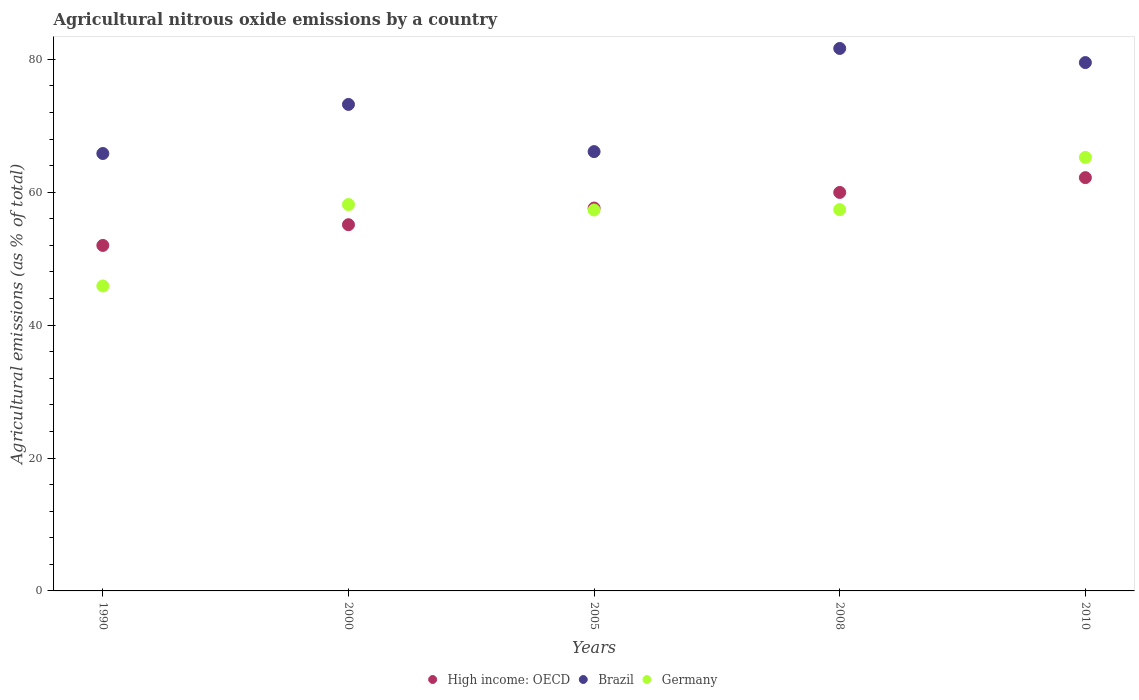How many different coloured dotlines are there?
Make the answer very short. 3. Is the number of dotlines equal to the number of legend labels?
Ensure brevity in your answer.  Yes. What is the amount of agricultural nitrous oxide emitted in Brazil in 2008?
Your answer should be very brief. 81.63. Across all years, what is the maximum amount of agricultural nitrous oxide emitted in High income: OECD?
Your response must be concise. 62.19. Across all years, what is the minimum amount of agricultural nitrous oxide emitted in High income: OECD?
Offer a terse response. 51.99. In which year was the amount of agricultural nitrous oxide emitted in High income: OECD minimum?
Keep it short and to the point. 1990. What is the total amount of agricultural nitrous oxide emitted in Germany in the graph?
Provide a succinct answer. 283.97. What is the difference between the amount of agricultural nitrous oxide emitted in Germany in 2008 and that in 2010?
Give a very brief answer. -7.85. What is the difference between the amount of agricultural nitrous oxide emitted in High income: OECD in 2010 and the amount of agricultural nitrous oxide emitted in Germany in 2008?
Your answer should be compact. 4.81. What is the average amount of agricultural nitrous oxide emitted in High income: OECD per year?
Provide a short and direct response. 57.37. In the year 2000, what is the difference between the amount of agricultural nitrous oxide emitted in High income: OECD and amount of agricultural nitrous oxide emitted in Brazil?
Keep it short and to the point. -18.1. What is the ratio of the amount of agricultural nitrous oxide emitted in High income: OECD in 2000 to that in 2010?
Provide a succinct answer. 0.89. Is the amount of agricultural nitrous oxide emitted in Germany in 2008 less than that in 2010?
Make the answer very short. Yes. Is the difference between the amount of agricultural nitrous oxide emitted in High income: OECD in 2000 and 2010 greater than the difference between the amount of agricultural nitrous oxide emitted in Brazil in 2000 and 2010?
Offer a very short reply. No. What is the difference between the highest and the second highest amount of agricultural nitrous oxide emitted in Brazil?
Provide a succinct answer. 2.12. What is the difference between the highest and the lowest amount of agricultural nitrous oxide emitted in High income: OECD?
Offer a terse response. 10.2. In how many years, is the amount of agricultural nitrous oxide emitted in Germany greater than the average amount of agricultural nitrous oxide emitted in Germany taken over all years?
Provide a short and direct response. 4. Is the sum of the amount of agricultural nitrous oxide emitted in High income: OECD in 2000 and 2008 greater than the maximum amount of agricultural nitrous oxide emitted in Brazil across all years?
Keep it short and to the point. Yes. Is the amount of agricultural nitrous oxide emitted in Germany strictly less than the amount of agricultural nitrous oxide emitted in Brazil over the years?
Provide a short and direct response. Yes. What is the difference between two consecutive major ticks on the Y-axis?
Your answer should be very brief. 20. Does the graph contain any zero values?
Ensure brevity in your answer.  No. Where does the legend appear in the graph?
Offer a very short reply. Bottom center. How many legend labels are there?
Keep it short and to the point. 3. What is the title of the graph?
Give a very brief answer. Agricultural nitrous oxide emissions by a country. What is the label or title of the X-axis?
Offer a very short reply. Years. What is the label or title of the Y-axis?
Your answer should be compact. Agricultural emissions (as % of total). What is the Agricultural emissions (as % of total) in High income: OECD in 1990?
Your response must be concise. 51.99. What is the Agricultural emissions (as % of total) in Brazil in 1990?
Ensure brevity in your answer.  65.82. What is the Agricultural emissions (as % of total) of Germany in 1990?
Make the answer very short. 45.89. What is the Agricultural emissions (as % of total) of High income: OECD in 2000?
Give a very brief answer. 55.1. What is the Agricultural emissions (as % of total) of Brazil in 2000?
Your answer should be very brief. 73.21. What is the Agricultural emissions (as % of total) of Germany in 2000?
Your answer should be very brief. 58.14. What is the Agricultural emissions (as % of total) in High income: OECD in 2005?
Give a very brief answer. 57.61. What is the Agricultural emissions (as % of total) in Brazil in 2005?
Your answer should be very brief. 66.11. What is the Agricultural emissions (as % of total) of Germany in 2005?
Offer a terse response. 57.32. What is the Agricultural emissions (as % of total) of High income: OECD in 2008?
Keep it short and to the point. 59.96. What is the Agricultural emissions (as % of total) of Brazil in 2008?
Your answer should be compact. 81.63. What is the Agricultural emissions (as % of total) in Germany in 2008?
Keep it short and to the point. 57.38. What is the Agricultural emissions (as % of total) in High income: OECD in 2010?
Provide a short and direct response. 62.19. What is the Agricultural emissions (as % of total) of Brazil in 2010?
Give a very brief answer. 79.5. What is the Agricultural emissions (as % of total) in Germany in 2010?
Ensure brevity in your answer.  65.23. Across all years, what is the maximum Agricultural emissions (as % of total) of High income: OECD?
Provide a succinct answer. 62.19. Across all years, what is the maximum Agricultural emissions (as % of total) of Brazil?
Give a very brief answer. 81.63. Across all years, what is the maximum Agricultural emissions (as % of total) in Germany?
Your answer should be very brief. 65.23. Across all years, what is the minimum Agricultural emissions (as % of total) of High income: OECD?
Provide a short and direct response. 51.99. Across all years, what is the minimum Agricultural emissions (as % of total) of Brazil?
Keep it short and to the point. 65.82. Across all years, what is the minimum Agricultural emissions (as % of total) in Germany?
Offer a terse response. 45.89. What is the total Agricultural emissions (as % of total) in High income: OECD in the graph?
Make the answer very short. 286.86. What is the total Agricultural emissions (as % of total) in Brazil in the graph?
Keep it short and to the point. 366.26. What is the total Agricultural emissions (as % of total) in Germany in the graph?
Offer a terse response. 283.97. What is the difference between the Agricultural emissions (as % of total) in High income: OECD in 1990 and that in 2000?
Offer a very short reply. -3.12. What is the difference between the Agricultural emissions (as % of total) of Brazil in 1990 and that in 2000?
Offer a terse response. -7.39. What is the difference between the Agricultural emissions (as % of total) of Germany in 1990 and that in 2000?
Ensure brevity in your answer.  -12.25. What is the difference between the Agricultural emissions (as % of total) in High income: OECD in 1990 and that in 2005?
Keep it short and to the point. -5.62. What is the difference between the Agricultural emissions (as % of total) in Brazil in 1990 and that in 2005?
Ensure brevity in your answer.  -0.29. What is the difference between the Agricultural emissions (as % of total) in Germany in 1990 and that in 2005?
Provide a short and direct response. -11.43. What is the difference between the Agricultural emissions (as % of total) of High income: OECD in 1990 and that in 2008?
Your answer should be compact. -7.97. What is the difference between the Agricultural emissions (as % of total) of Brazil in 1990 and that in 2008?
Your answer should be very brief. -15.81. What is the difference between the Agricultural emissions (as % of total) of Germany in 1990 and that in 2008?
Provide a succinct answer. -11.49. What is the difference between the Agricultural emissions (as % of total) in High income: OECD in 1990 and that in 2010?
Your answer should be compact. -10.2. What is the difference between the Agricultural emissions (as % of total) of Brazil in 1990 and that in 2010?
Your answer should be very brief. -13.68. What is the difference between the Agricultural emissions (as % of total) in Germany in 1990 and that in 2010?
Provide a short and direct response. -19.34. What is the difference between the Agricultural emissions (as % of total) of High income: OECD in 2000 and that in 2005?
Offer a terse response. -2.51. What is the difference between the Agricultural emissions (as % of total) in Brazil in 2000 and that in 2005?
Make the answer very short. 7.1. What is the difference between the Agricultural emissions (as % of total) in Germany in 2000 and that in 2005?
Offer a terse response. 0.82. What is the difference between the Agricultural emissions (as % of total) of High income: OECD in 2000 and that in 2008?
Your answer should be compact. -4.86. What is the difference between the Agricultural emissions (as % of total) of Brazil in 2000 and that in 2008?
Provide a short and direct response. -8.42. What is the difference between the Agricultural emissions (as % of total) of Germany in 2000 and that in 2008?
Make the answer very short. 0.76. What is the difference between the Agricultural emissions (as % of total) of High income: OECD in 2000 and that in 2010?
Offer a very short reply. -7.09. What is the difference between the Agricultural emissions (as % of total) of Brazil in 2000 and that in 2010?
Offer a terse response. -6.3. What is the difference between the Agricultural emissions (as % of total) of Germany in 2000 and that in 2010?
Ensure brevity in your answer.  -7.09. What is the difference between the Agricultural emissions (as % of total) of High income: OECD in 2005 and that in 2008?
Your answer should be very brief. -2.35. What is the difference between the Agricultural emissions (as % of total) of Brazil in 2005 and that in 2008?
Keep it short and to the point. -15.52. What is the difference between the Agricultural emissions (as % of total) in Germany in 2005 and that in 2008?
Give a very brief answer. -0.06. What is the difference between the Agricultural emissions (as % of total) in High income: OECD in 2005 and that in 2010?
Provide a succinct answer. -4.58. What is the difference between the Agricultural emissions (as % of total) in Brazil in 2005 and that in 2010?
Your answer should be very brief. -13.4. What is the difference between the Agricultural emissions (as % of total) in Germany in 2005 and that in 2010?
Your answer should be compact. -7.91. What is the difference between the Agricultural emissions (as % of total) in High income: OECD in 2008 and that in 2010?
Your response must be concise. -2.23. What is the difference between the Agricultural emissions (as % of total) of Brazil in 2008 and that in 2010?
Your response must be concise. 2.12. What is the difference between the Agricultural emissions (as % of total) of Germany in 2008 and that in 2010?
Your answer should be very brief. -7.86. What is the difference between the Agricultural emissions (as % of total) in High income: OECD in 1990 and the Agricultural emissions (as % of total) in Brazil in 2000?
Provide a short and direct response. -21.22. What is the difference between the Agricultural emissions (as % of total) in High income: OECD in 1990 and the Agricultural emissions (as % of total) in Germany in 2000?
Provide a short and direct response. -6.15. What is the difference between the Agricultural emissions (as % of total) of Brazil in 1990 and the Agricultural emissions (as % of total) of Germany in 2000?
Offer a terse response. 7.68. What is the difference between the Agricultural emissions (as % of total) of High income: OECD in 1990 and the Agricultural emissions (as % of total) of Brazil in 2005?
Ensure brevity in your answer.  -14.12. What is the difference between the Agricultural emissions (as % of total) of High income: OECD in 1990 and the Agricultural emissions (as % of total) of Germany in 2005?
Provide a short and direct response. -5.33. What is the difference between the Agricultural emissions (as % of total) of Brazil in 1990 and the Agricultural emissions (as % of total) of Germany in 2005?
Your answer should be compact. 8.5. What is the difference between the Agricultural emissions (as % of total) of High income: OECD in 1990 and the Agricultural emissions (as % of total) of Brazil in 2008?
Your answer should be very brief. -29.64. What is the difference between the Agricultural emissions (as % of total) of High income: OECD in 1990 and the Agricultural emissions (as % of total) of Germany in 2008?
Offer a terse response. -5.39. What is the difference between the Agricultural emissions (as % of total) in Brazil in 1990 and the Agricultural emissions (as % of total) in Germany in 2008?
Keep it short and to the point. 8.44. What is the difference between the Agricultural emissions (as % of total) in High income: OECD in 1990 and the Agricultural emissions (as % of total) in Brazil in 2010?
Your answer should be compact. -27.52. What is the difference between the Agricultural emissions (as % of total) of High income: OECD in 1990 and the Agricultural emissions (as % of total) of Germany in 2010?
Give a very brief answer. -13.25. What is the difference between the Agricultural emissions (as % of total) in Brazil in 1990 and the Agricultural emissions (as % of total) in Germany in 2010?
Provide a short and direct response. 0.59. What is the difference between the Agricultural emissions (as % of total) in High income: OECD in 2000 and the Agricultural emissions (as % of total) in Brazil in 2005?
Make the answer very short. -11. What is the difference between the Agricultural emissions (as % of total) in High income: OECD in 2000 and the Agricultural emissions (as % of total) in Germany in 2005?
Your answer should be compact. -2.22. What is the difference between the Agricultural emissions (as % of total) in Brazil in 2000 and the Agricultural emissions (as % of total) in Germany in 2005?
Offer a very short reply. 15.89. What is the difference between the Agricultural emissions (as % of total) in High income: OECD in 2000 and the Agricultural emissions (as % of total) in Brazil in 2008?
Make the answer very short. -26.52. What is the difference between the Agricultural emissions (as % of total) of High income: OECD in 2000 and the Agricultural emissions (as % of total) of Germany in 2008?
Your response must be concise. -2.27. What is the difference between the Agricultural emissions (as % of total) in Brazil in 2000 and the Agricultural emissions (as % of total) in Germany in 2008?
Your answer should be very brief. 15.83. What is the difference between the Agricultural emissions (as % of total) in High income: OECD in 2000 and the Agricultural emissions (as % of total) in Brazil in 2010?
Provide a short and direct response. -24.4. What is the difference between the Agricultural emissions (as % of total) of High income: OECD in 2000 and the Agricultural emissions (as % of total) of Germany in 2010?
Make the answer very short. -10.13. What is the difference between the Agricultural emissions (as % of total) in Brazil in 2000 and the Agricultural emissions (as % of total) in Germany in 2010?
Your answer should be compact. 7.97. What is the difference between the Agricultural emissions (as % of total) of High income: OECD in 2005 and the Agricultural emissions (as % of total) of Brazil in 2008?
Your answer should be very brief. -24.02. What is the difference between the Agricultural emissions (as % of total) of High income: OECD in 2005 and the Agricultural emissions (as % of total) of Germany in 2008?
Offer a very short reply. 0.23. What is the difference between the Agricultural emissions (as % of total) of Brazil in 2005 and the Agricultural emissions (as % of total) of Germany in 2008?
Provide a succinct answer. 8.73. What is the difference between the Agricultural emissions (as % of total) of High income: OECD in 2005 and the Agricultural emissions (as % of total) of Brazil in 2010?
Your response must be concise. -21.89. What is the difference between the Agricultural emissions (as % of total) of High income: OECD in 2005 and the Agricultural emissions (as % of total) of Germany in 2010?
Offer a terse response. -7.62. What is the difference between the Agricultural emissions (as % of total) in Brazil in 2005 and the Agricultural emissions (as % of total) in Germany in 2010?
Ensure brevity in your answer.  0.87. What is the difference between the Agricultural emissions (as % of total) in High income: OECD in 2008 and the Agricultural emissions (as % of total) in Brazil in 2010?
Keep it short and to the point. -19.54. What is the difference between the Agricultural emissions (as % of total) of High income: OECD in 2008 and the Agricultural emissions (as % of total) of Germany in 2010?
Provide a succinct answer. -5.27. What is the difference between the Agricultural emissions (as % of total) in Brazil in 2008 and the Agricultural emissions (as % of total) in Germany in 2010?
Provide a succinct answer. 16.39. What is the average Agricultural emissions (as % of total) in High income: OECD per year?
Your answer should be compact. 57.37. What is the average Agricultural emissions (as % of total) in Brazil per year?
Keep it short and to the point. 73.25. What is the average Agricultural emissions (as % of total) of Germany per year?
Your answer should be very brief. 56.79. In the year 1990, what is the difference between the Agricultural emissions (as % of total) of High income: OECD and Agricultural emissions (as % of total) of Brazil?
Give a very brief answer. -13.83. In the year 1990, what is the difference between the Agricultural emissions (as % of total) of High income: OECD and Agricultural emissions (as % of total) of Germany?
Make the answer very short. 6.1. In the year 1990, what is the difference between the Agricultural emissions (as % of total) in Brazil and Agricultural emissions (as % of total) in Germany?
Your answer should be very brief. 19.93. In the year 2000, what is the difference between the Agricultural emissions (as % of total) in High income: OECD and Agricultural emissions (as % of total) in Brazil?
Keep it short and to the point. -18.1. In the year 2000, what is the difference between the Agricultural emissions (as % of total) of High income: OECD and Agricultural emissions (as % of total) of Germany?
Keep it short and to the point. -3.04. In the year 2000, what is the difference between the Agricultural emissions (as % of total) in Brazil and Agricultural emissions (as % of total) in Germany?
Your response must be concise. 15.06. In the year 2005, what is the difference between the Agricultural emissions (as % of total) in High income: OECD and Agricultural emissions (as % of total) in Brazil?
Give a very brief answer. -8.49. In the year 2005, what is the difference between the Agricultural emissions (as % of total) of High income: OECD and Agricultural emissions (as % of total) of Germany?
Ensure brevity in your answer.  0.29. In the year 2005, what is the difference between the Agricultural emissions (as % of total) of Brazil and Agricultural emissions (as % of total) of Germany?
Ensure brevity in your answer.  8.79. In the year 2008, what is the difference between the Agricultural emissions (as % of total) of High income: OECD and Agricultural emissions (as % of total) of Brazil?
Your answer should be compact. -21.67. In the year 2008, what is the difference between the Agricultural emissions (as % of total) in High income: OECD and Agricultural emissions (as % of total) in Germany?
Ensure brevity in your answer.  2.58. In the year 2008, what is the difference between the Agricultural emissions (as % of total) of Brazil and Agricultural emissions (as % of total) of Germany?
Offer a very short reply. 24.25. In the year 2010, what is the difference between the Agricultural emissions (as % of total) in High income: OECD and Agricultural emissions (as % of total) in Brazil?
Your answer should be compact. -17.31. In the year 2010, what is the difference between the Agricultural emissions (as % of total) of High income: OECD and Agricultural emissions (as % of total) of Germany?
Your answer should be compact. -3.04. In the year 2010, what is the difference between the Agricultural emissions (as % of total) in Brazil and Agricultural emissions (as % of total) in Germany?
Keep it short and to the point. 14.27. What is the ratio of the Agricultural emissions (as % of total) of High income: OECD in 1990 to that in 2000?
Your answer should be very brief. 0.94. What is the ratio of the Agricultural emissions (as % of total) of Brazil in 1990 to that in 2000?
Offer a terse response. 0.9. What is the ratio of the Agricultural emissions (as % of total) of Germany in 1990 to that in 2000?
Your answer should be very brief. 0.79. What is the ratio of the Agricultural emissions (as % of total) in High income: OECD in 1990 to that in 2005?
Give a very brief answer. 0.9. What is the ratio of the Agricultural emissions (as % of total) of Germany in 1990 to that in 2005?
Your response must be concise. 0.8. What is the ratio of the Agricultural emissions (as % of total) of High income: OECD in 1990 to that in 2008?
Offer a terse response. 0.87. What is the ratio of the Agricultural emissions (as % of total) in Brazil in 1990 to that in 2008?
Provide a succinct answer. 0.81. What is the ratio of the Agricultural emissions (as % of total) in Germany in 1990 to that in 2008?
Your answer should be very brief. 0.8. What is the ratio of the Agricultural emissions (as % of total) in High income: OECD in 1990 to that in 2010?
Keep it short and to the point. 0.84. What is the ratio of the Agricultural emissions (as % of total) of Brazil in 1990 to that in 2010?
Keep it short and to the point. 0.83. What is the ratio of the Agricultural emissions (as % of total) of Germany in 1990 to that in 2010?
Make the answer very short. 0.7. What is the ratio of the Agricultural emissions (as % of total) in High income: OECD in 2000 to that in 2005?
Your response must be concise. 0.96. What is the ratio of the Agricultural emissions (as % of total) in Brazil in 2000 to that in 2005?
Your answer should be very brief. 1.11. What is the ratio of the Agricultural emissions (as % of total) in Germany in 2000 to that in 2005?
Make the answer very short. 1.01. What is the ratio of the Agricultural emissions (as % of total) in High income: OECD in 2000 to that in 2008?
Provide a succinct answer. 0.92. What is the ratio of the Agricultural emissions (as % of total) in Brazil in 2000 to that in 2008?
Your response must be concise. 0.9. What is the ratio of the Agricultural emissions (as % of total) of Germany in 2000 to that in 2008?
Give a very brief answer. 1.01. What is the ratio of the Agricultural emissions (as % of total) in High income: OECD in 2000 to that in 2010?
Ensure brevity in your answer.  0.89. What is the ratio of the Agricultural emissions (as % of total) of Brazil in 2000 to that in 2010?
Keep it short and to the point. 0.92. What is the ratio of the Agricultural emissions (as % of total) of Germany in 2000 to that in 2010?
Provide a succinct answer. 0.89. What is the ratio of the Agricultural emissions (as % of total) in High income: OECD in 2005 to that in 2008?
Offer a very short reply. 0.96. What is the ratio of the Agricultural emissions (as % of total) of Brazil in 2005 to that in 2008?
Your answer should be compact. 0.81. What is the ratio of the Agricultural emissions (as % of total) of Germany in 2005 to that in 2008?
Provide a short and direct response. 1. What is the ratio of the Agricultural emissions (as % of total) in High income: OECD in 2005 to that in 2010?
Offer a very short reply. 0.93. What is the ratio of the Agricultural emissions (as % of total) of Brazil in 2005 to that in 2010?
Offer a very short reply. 0.83. What is the ratio of the Agricultural emissions (as % of total) of Germany in 2005 to that in 2010?
Provide a short and direct response. 0.88. What is the ratio of the Agricultural emissions (as % of total) of High income: OECD in 2008 to that in 2010?
Your answer should be very brief. 0.96. What is the ratio of the Agricultural emissions (as % of total) in Brazil in 2008 to that in 2010?
Offer a terse response. 1.03. What is the ratio of the Agricultural emissions (as % of total) in Germany in 2008 to that in 2010?
Keep it short and to the point. 0.88. What is the difference between the highest and the second highest Agricultural emissions (as % of total) in High income: OECD?
Give a very brief answer. 2.23. What is the difference between the highest and the second highest Agricultural emissions (as % of total) in Brazil?
Offer a terse response. 2.12. What is the difference between the highest and the second highest Agricultural emissions (as % of total) of Germany?
Keep it short and to the point. 7.09. What is the difference between the highest and the lowest Agricultural emissions (as % of total) in High income: OECD?
Ensure brevity in your answer.  10.2. What is the difference between the highest and the lowest Agricultural emissions (as % of total) of Brazil?
Give a very brief answer. 15.81. What is the difference between the highest and the lowest Agricultural emissions (as % of total) in Germany?
Offer a very short reply. 19.34. 